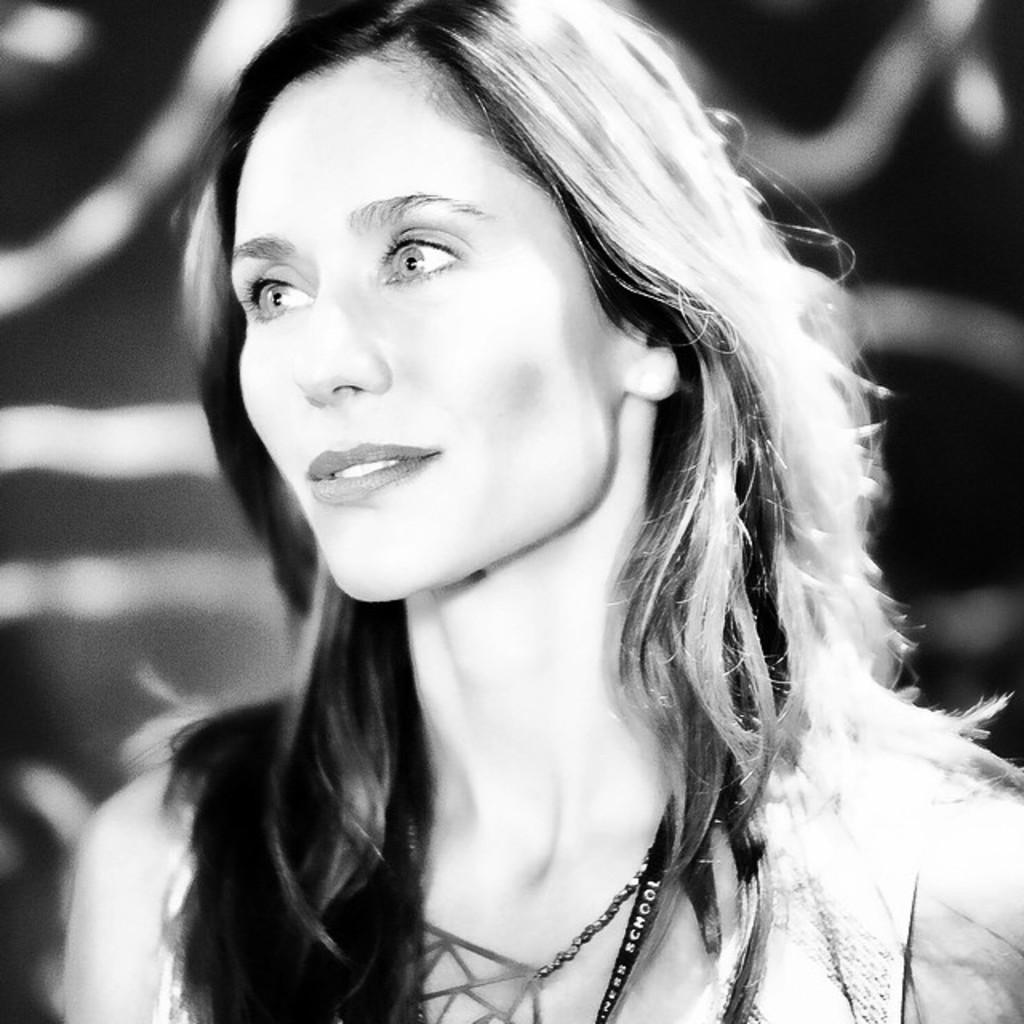Who is the main subject in the image? There is a woman in the image. What can be observed about the background of the image? The background of the image is blurred. What type of horse is present in the image? There is no horse present in the image; it only features a woman with a blurred background. What role does the woman play in the army in the image? There is no army or military context in the image; it simply shows a woman with a blurred background. 